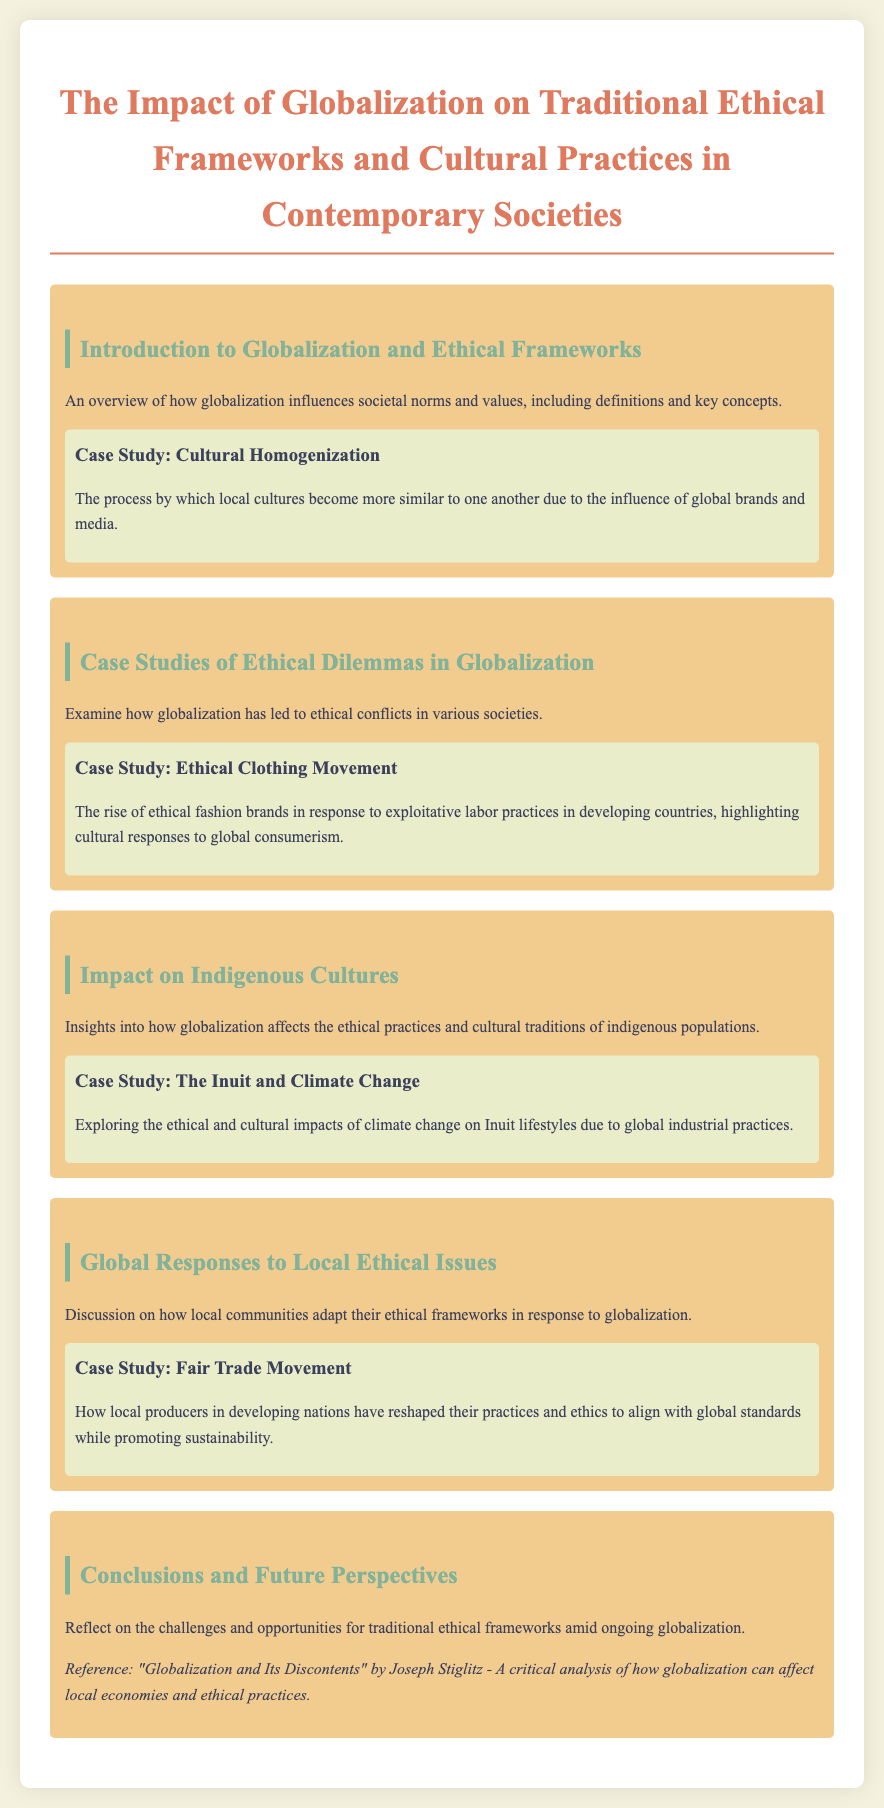what is the title of the document? The title is presented at the top of the document, emphasizing the main subject.
Answer: The Impact of Globalization on Traditional Ethical Frameworks and Cultural Practices in Contemporary Societies what is a key aspect of globalization discussed in the introduction? The introduction outlines how globalization influences societal norms and values, which forms the initial context of the document.
Answer: Societal norms and values what case study focuses on cultural homogenization? This case study is specifically highlighted under the introduction section, addressing the blending of local cultures.
Answer: Cultural Homogenization which case study addresses the ethical clothing movement? This case study examines a modern ethical dilemma related to consumerism and labor practices globally.
Answer: Ethical Clothing Movement what impact does globalization have on indigenous cultures? The document provides insights into the effects on ethical practices and cultural traditions.
Answer: Ethical practices and cultural traditions what do local communities adapt in response to globalization? This adaptation is discussed in the context of how communities modify their ethical frameworks.
Answer: Ethical frameworks who wrote the reference book mentioned in the conclusions? The author of the referenced book provides a critical analysis of globalization's effects.
Answer: Joseph Stiglitz what movement is associated with local producers reshaping practices? This movement is explored as a global response to ethical issues for local producers.
Answer: Fair Trade Movement what is the main focus of the case study on the Inuit? This case study explores the impact of environmental changes on a specific group's lifestyle.
Answer: Climate Change 